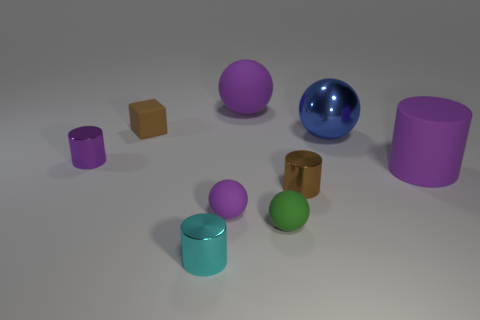Add 1 purple cylinders. How many objects exist? 10 Subtract all shiny cylinders. How many cylinders are left? 1 Subtract 1 blocks. How many blocks are left? 0 Subtract all brown cylinders. How many cylinders are left? 3 Subtract all spheres. How many objects are left? 5 Subtract all red cubes. Subtract all gray cylinders. How many cubes are left? 1 Subtract all purple balls. How many cyan cubes are left? 0 Subtract all tiny rubber balls. Subtract all small purple rubber spheres. How many objects are left? 6 Add 1 blue metallic objects. How many blue metallic objects are left? 2 Add 8 small gray cubes. How many small gray cubes exist? 8 